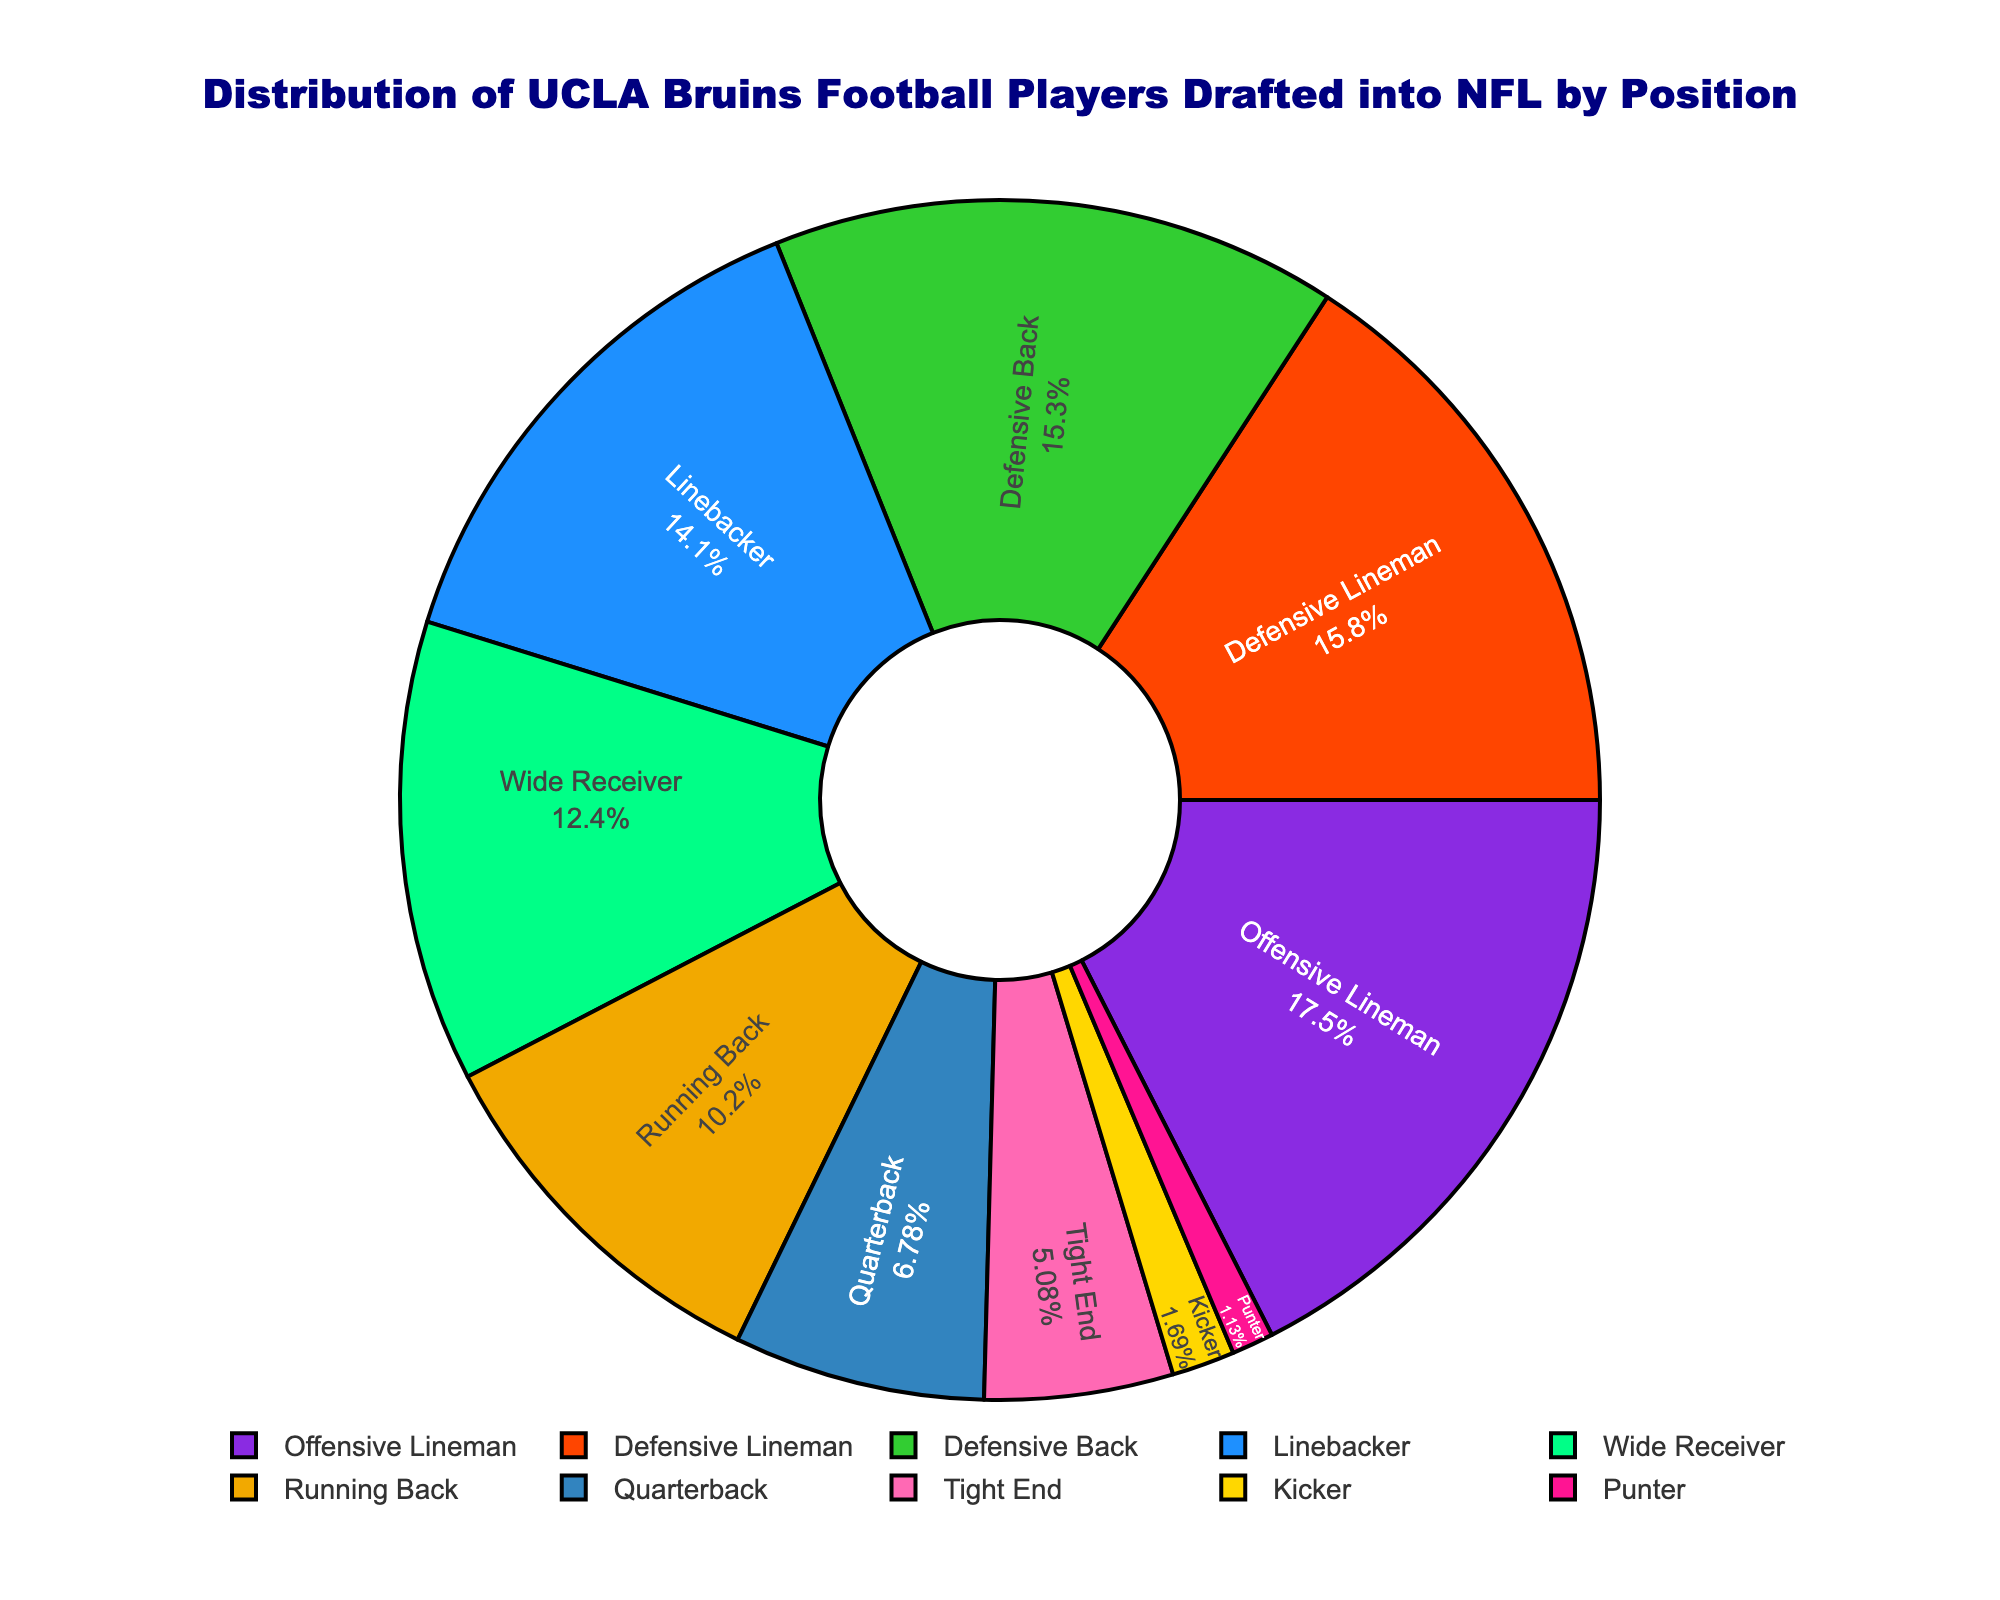Which position has the largest proportion of UCLA Bruins football players drafted into the NFL? The pie chart visually represents the distribution of UCLA Bruins football players drafted into the NFL by position. The segment corresponding to Offensive Lineman is visibly the largest.
Answer: Offensive Lineman What is the combined percentage of players drafted as Linebackers and Defensive Backs? The pie chart shows the individual percentages for each position. Summing the percentages for Linebackers and Defensive Backs gives the combined value.
Answer: 22% + 24% = 46% How does the percentage of drafted Quarterbacks compare to the percentage of Tight Ends? By examining the pie chart, we can compare the size of the segments. The segment for Tight Ends is smaller than the segment for Quarterbacks.
Answer: More Quarterbacks What is the difference in the number of players between the Offensive Lineman and Quarterbacks? The number of players drafted as Offensive Linemen is 31, and for Quarterbacks, it is 12. The difference is calculated as 31 - 12.
Answer: 19 What is the total percentage of Offensive and Defensive Linemen combined? Adding the individual percentages for Offensive Linemen and Defensive Linemen gives the combined percentage.
Answer: 31% + 28% = 59% What is the average number of players drafted for the positions of Running Back, Tight End, and Kicker? Adding the number of players for Running Back (18), Tight End (9), and Kicker (3), then dividing by 3 gives the average.
Answer: (18 + 9 + 3) / 3 = 10 What position has the smallest slice in the pie chart? By observing the pie chart, the position with the smallest slice is identified as Punter.
Answer: Punter Which has a larger proportion of drafted players: Wide Receivers or Linebackers? The pie chart shows the segments for Wide Receivers and Linebackers. The segment for Wide Receivers is larger.
Answer: Wide Receivers How many more players have been drafted as Defensive Linemen compared to Tight Ends? The number of players for Defensive Linemen is 28, and for Tight Ends, it is 9. The difference is calculated as 28 - 9.
Answer: 19 What is the percentage of players drafted into the NFL from the Kicker and Punter positions combined? Adding the individual percentages for Kickers and Punters gives the combined percentage.
Answer: 3% + 2% = 5% 